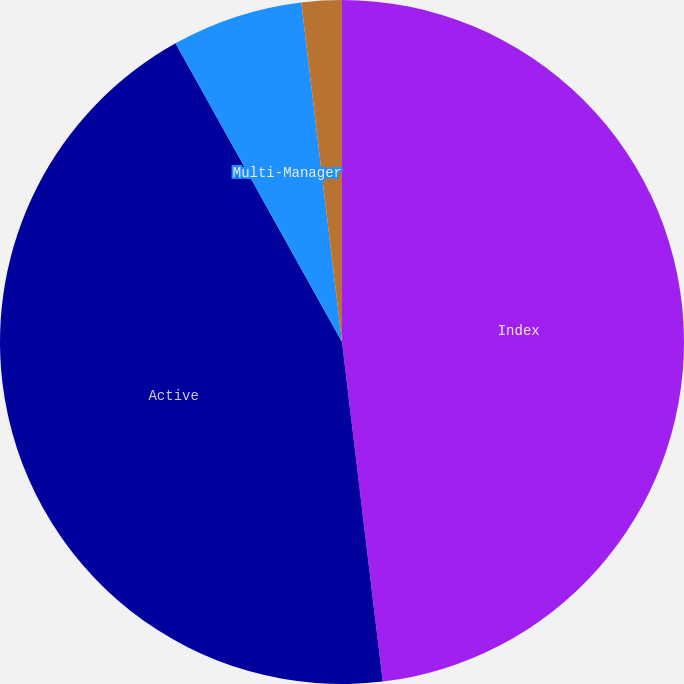Convert chart to OTSL. <chart><loc_0><loc_0><loc_500><loc_500><pie_chart><fcel>Index<fcel>Active<fcel>Multi-Manager<fcel>Other<nl><fcel>48.1%<fcel>43.81%<fcel>6.19%<fcel>1.9%<nl></chart> 